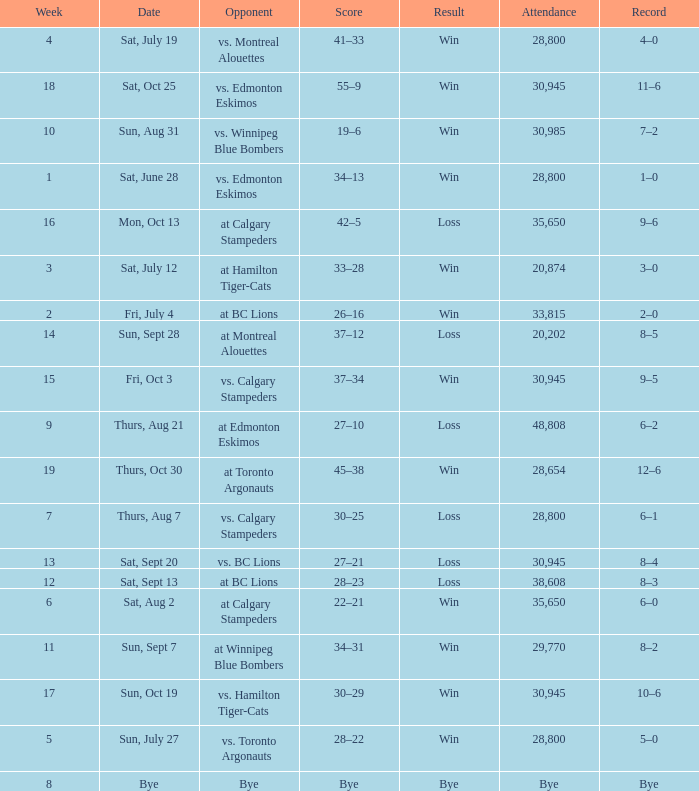What was the date of the game with an attendance of 20,874 fans? Sat, July 12. 